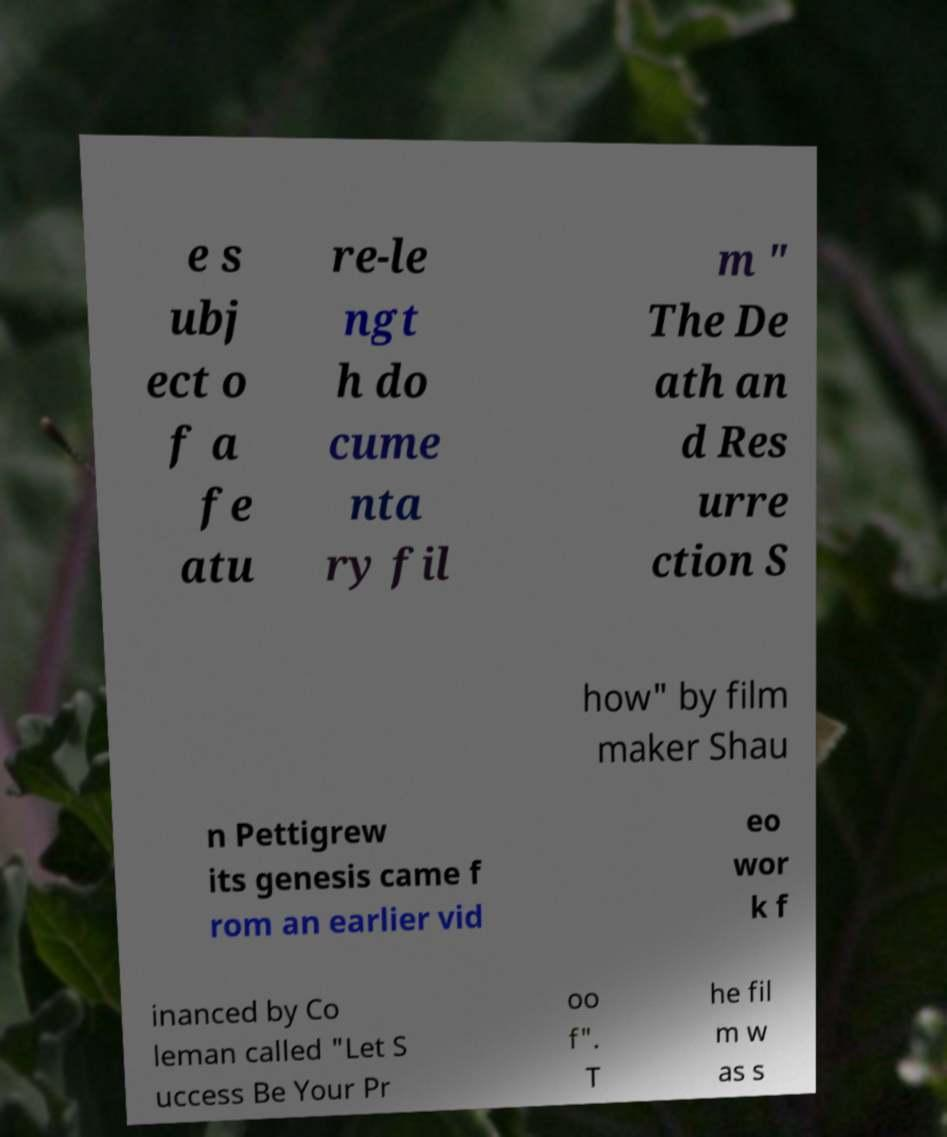There's text embedded in this image that I need extracted. Can you transcribe it verbatim? e s ubj ect o f a fe atu re-le ngt h do cume nta ry fil m " The De ath an d Res urre ction S how" by film maker Shau n Pettigrew its genesis came f rom an earlier vid eo wor k f inanced by Co leman called "Let S uccess Be Your Pr oo f". T he fil m w as s 